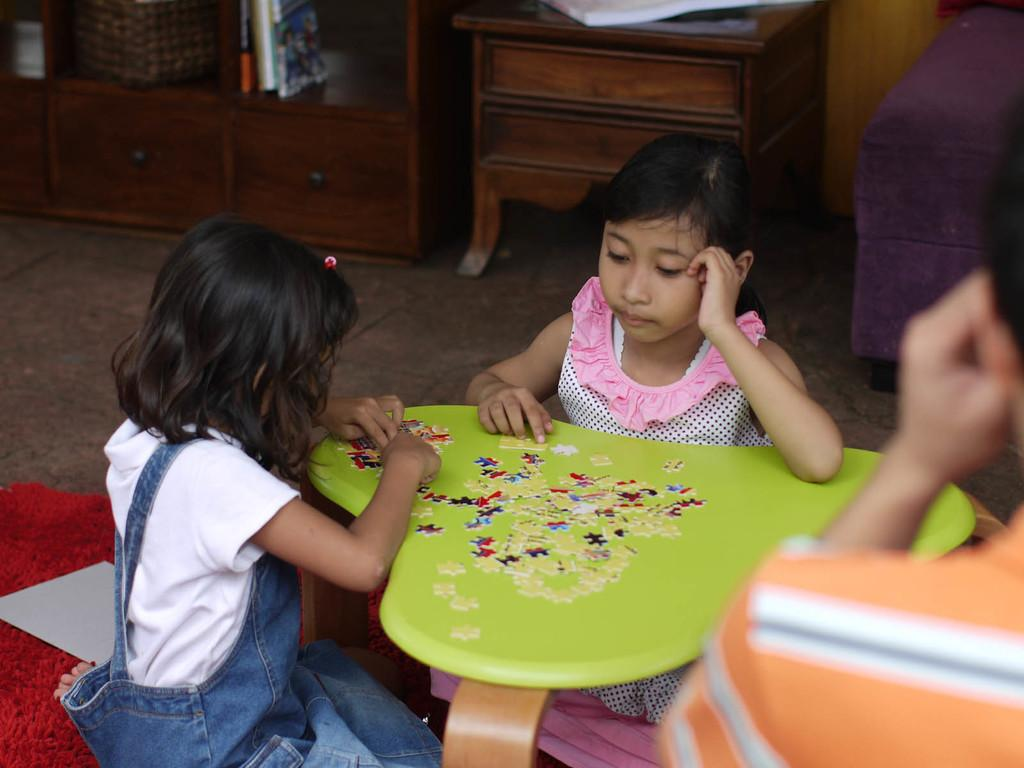How many girls are sitting on the floor in the image? There are two girls sitting on the floor in the image. What is in front of the girls? There is a table in front of the girls. What is on the table? There is a puzzle on the table. What can be seen in the background of the image? There are cabinets and a sofa in the background of the image. What date is marked on the calendar in the image? There is no calendar present in the image. What type of school is depicted in the image? The image does not show a school or any school-related activities. 